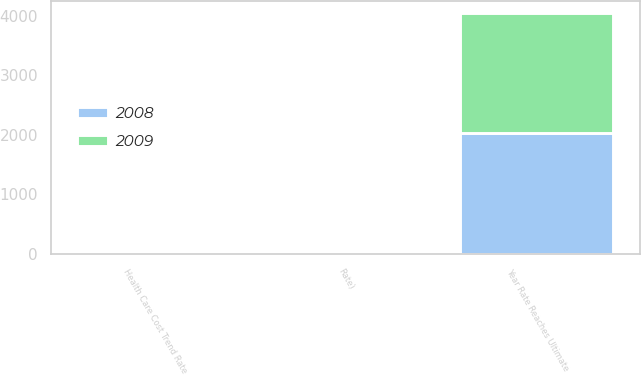Convert chart. <chart><loc_0><loc_0><loc_500><loc_500><stacked_bar_chart><ecel><fcel>Health Care Cost Trend Rate<fcel>Rate)<fcel>Year Rate Reaches Ultimate<nl><fcel>2008<fcel>8<fcel>4.5<fcel>2030<nl><fcel>2009<fcel>8<fcel>5<fcel>2012<nl></chart> 